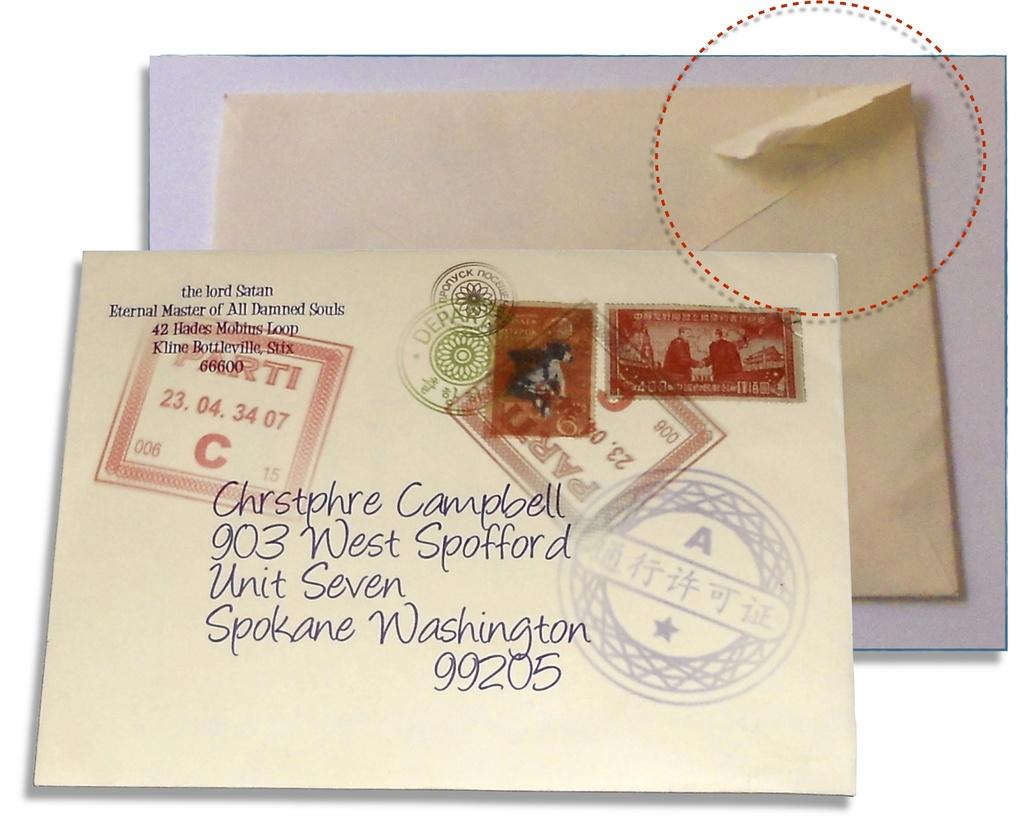<image>
Relay a brief, clear account of the picture shown. A letter addressed to Chrstphre Campbell was sent on 23.04. 